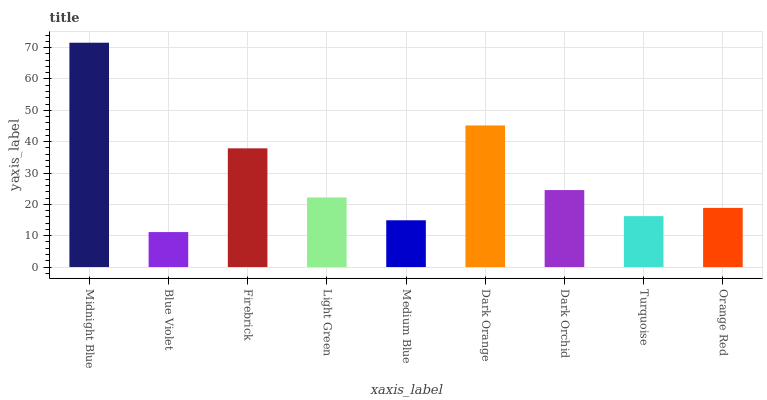Is Blue Violet the minimum?
Answer yes or no. Yes. Is Midnight Blue the maximum?
Answer yes or no. Yes. Is Firebrick the minimum?
Answer yes or no. No. Is Firebrick the maximum?
Answer yes or no. No. Is Firebrick greater than Blue Violet?
Answer yes or no. Yes. Is Blue Violet less than Firebrick?
Answer yes or no. Yes. Is Blue Violet greater than Firebrick?
Answer yes or no. No. Is Firebrick less than Blue Violet?
Answer yes or no. No. Is Light Green the high median?
Answer yes or no. Yes. Is Light Green the low median?
Answer yes or no. Yes. Is Turquoise the high median?
Answer yes or no. No. Is Dark Orange the low median?
Answer yes or no. No. 